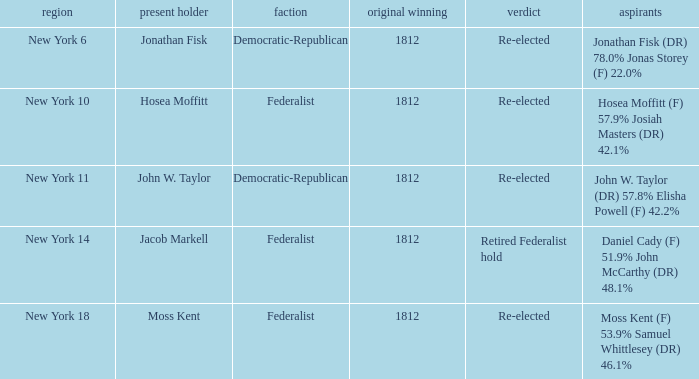Name the first elected for hosea moffitt (f) 57.9% josiah masters (dr) 42.1% 1812.0. 